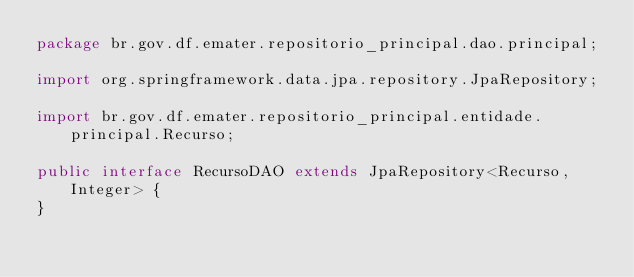<code> <loc_0><loc_0><loc_500><loc_500><_Java_>package br.gov.df.emater.repositorio_principal.dao.principal;

import org.springframework.data.jpa.repository.JpaRepository;

import br.gov.df.emater.repositorio_principal.entidade.principal.Recurso;

public interface RecursoDAO extends JpaRepository<Recurso, Integer> {
}</code> 